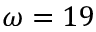<formula> <loc_0><loc_0><loc_500><loc_500>\omega = 1 9</formula> 